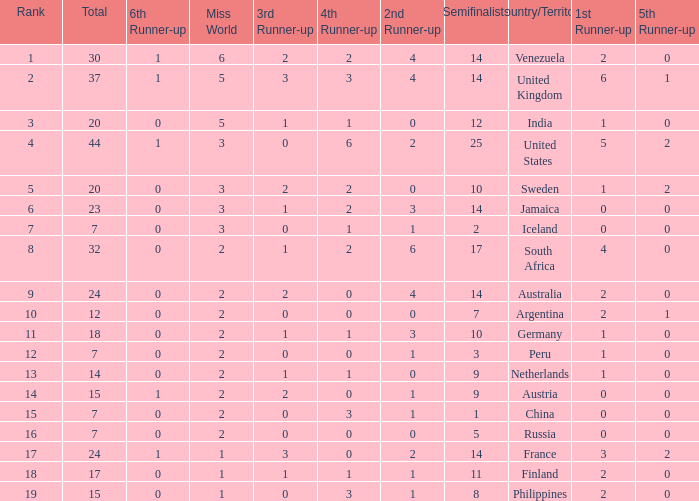What is Venezuela's total rank? 30.0. 